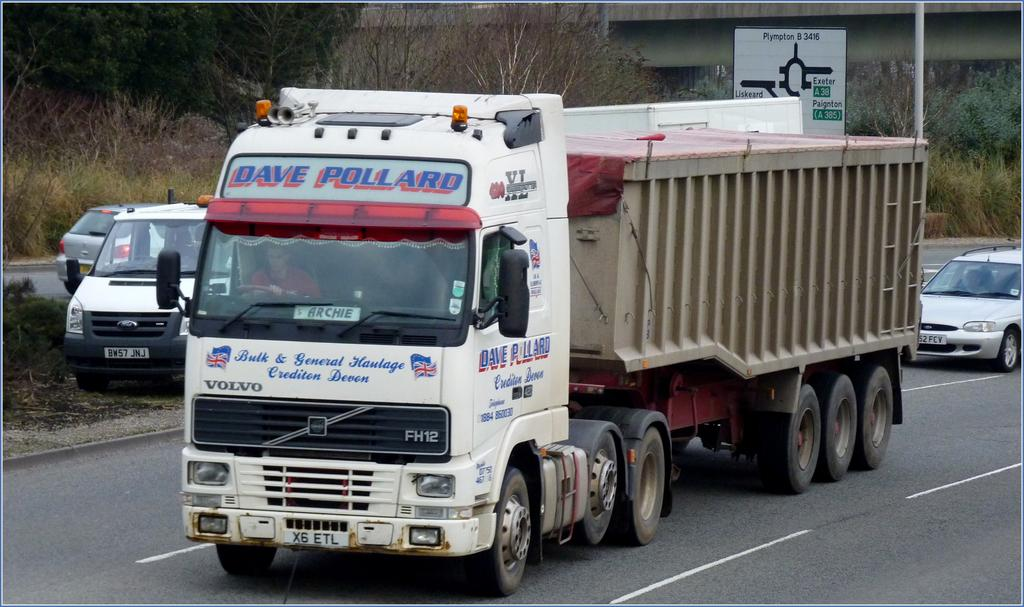What type of vehicle is the main subject in the image? There is a truck in the image. Are there any other vehicles present in the image? Yes, there are cars in the image. What can be seen hanging or displayed in the image? There is a banner in the image. What type of natural elements are visible in the image? There are trees in the image. What type of structure can be seen in the background of the image? There is a bridge in the background of the image. How many fingers can be seen on the worm in the image? There are no worms or fingers present in the image. What type of arithmetic problem is being solved on the banner in the image? There is no arithmetic problem visible on the banner in the image. 